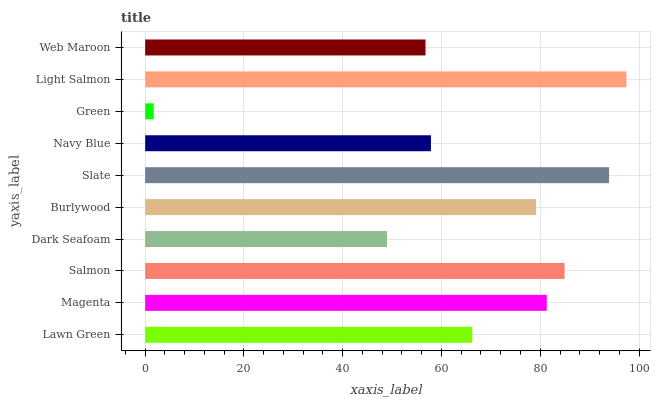Is Green the minimum?
Answer yes or no. Yes. Is Light Salmon the maximum?
Answer yes or no. Yes. Is Magenta the minimum?
Answer yes or no. No. Is Magenta the maximum?
Answer yes or no. No. Is Magenta greater than Lawn Green?
Answer yes or no. Yes. Is Lawn Green less than Magenta?
Answer yes or no. Yes. Is Lawn Green greater than Magenta?
Answer yes or no. No. Is Magenta less than Lawn Green?
Answer yes or no. No. Is Burlywood the high median?
Answer yes or no. Yes. Is Lawn Green the low median?
Answer yes or no. Yes. Is Navy Blue the high median?
Answer yes or no. No. Is Web Maroon the low median?
Answer yes or no. No. 